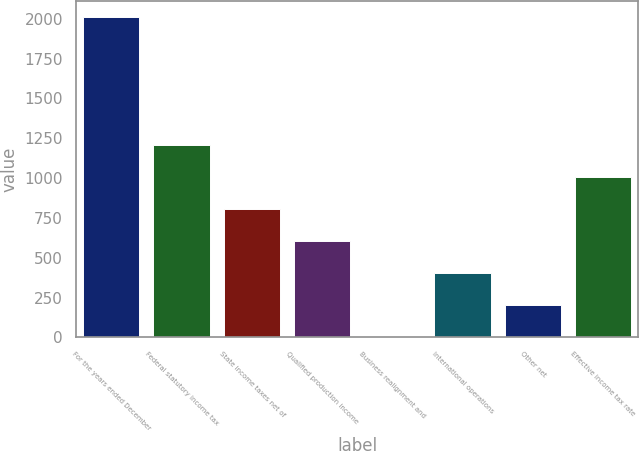Convert chart to OTSL. <chart><loc_0><loc_0><loc_500><loc_500><bar_chart><fcel>For the years ended December<fcel>Federal statutory income tax<fcel>State income taxes net of<fcel>Qualified production income<fcel>Business realignment and<fcel>International operations<fcel>Other net<fcel>Effective income tax rate<nl><fcel>2011<fcel>1206.64<fcel>804.46<fcel>603.37<fcel>0.1<fcel>402.28<fcel>201.19<fcel>1005.55<nl></chart> 